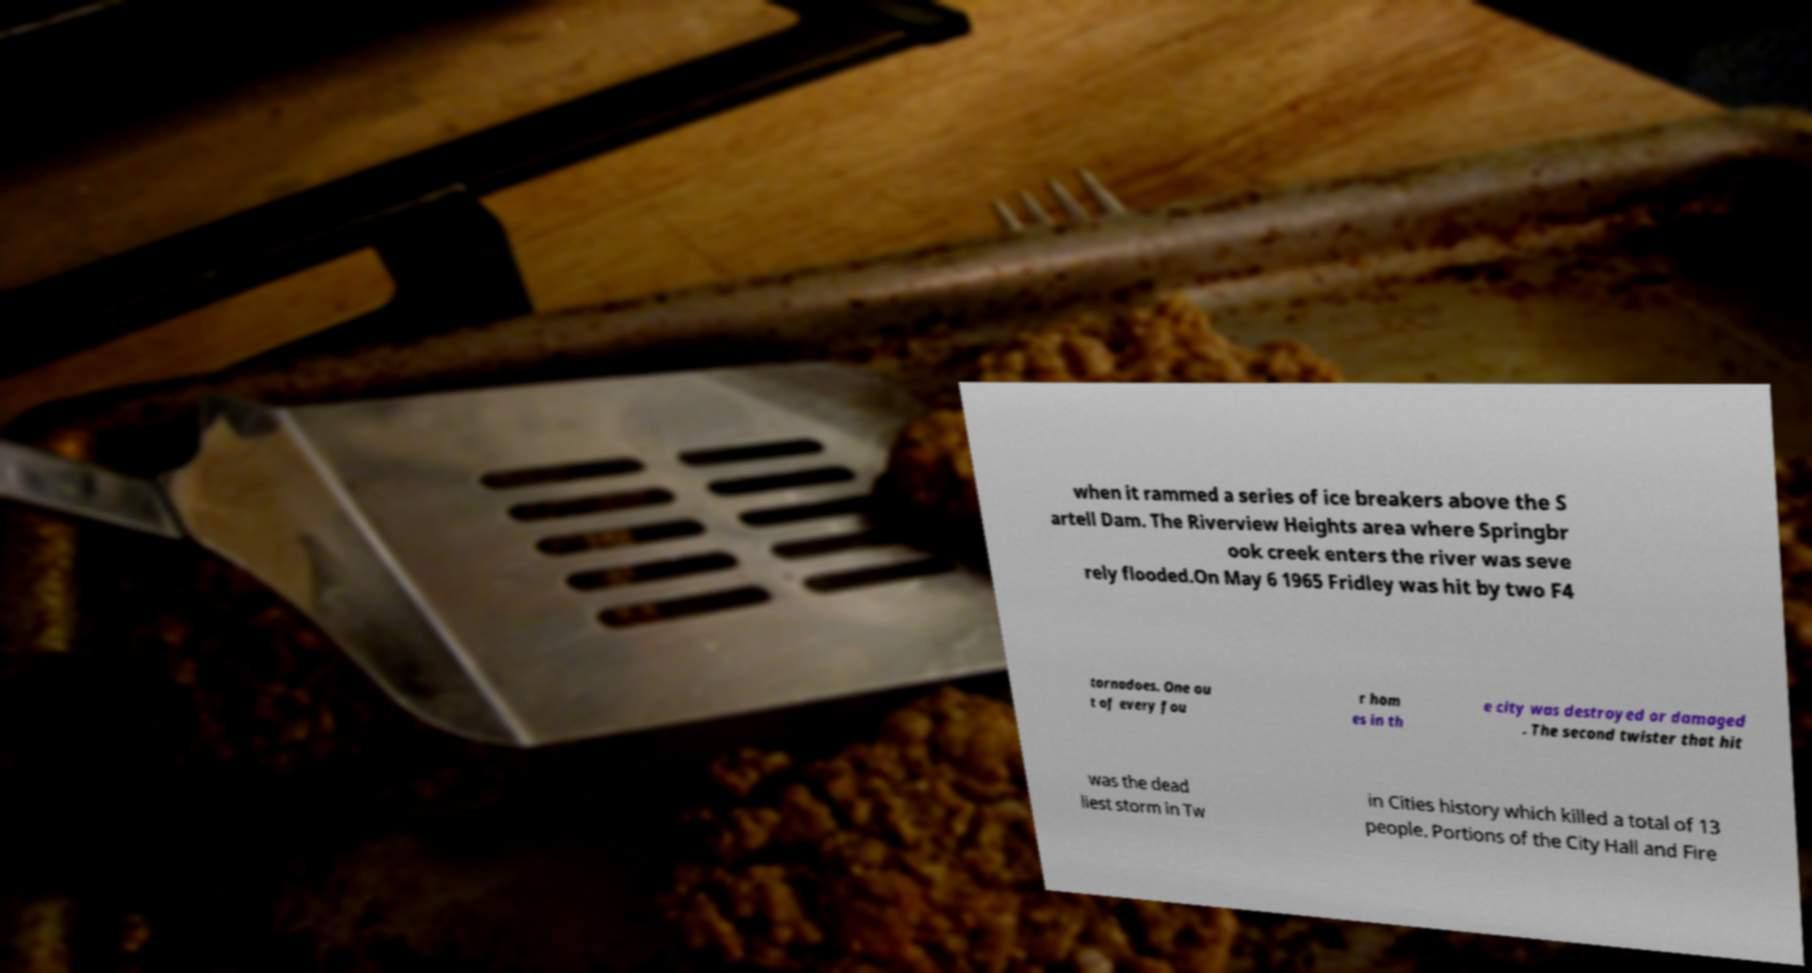What messages or text are displayed in this image? I need them in a readable, typed format. when it rammed a series of ice breakers above the S artell Dam. The Riverview Heights area where Springbr ook creek enters the river was seve rely flooded.On May 6 1965 Fridley was hit by two F4 tornadoes. One ou t of every fou r hom es in th e city was destroyed or damaged . The second twister that hit was the dead liest storm in Tw in Cities history which killed a total of 13 people. Portions of the City Hall and Fire 